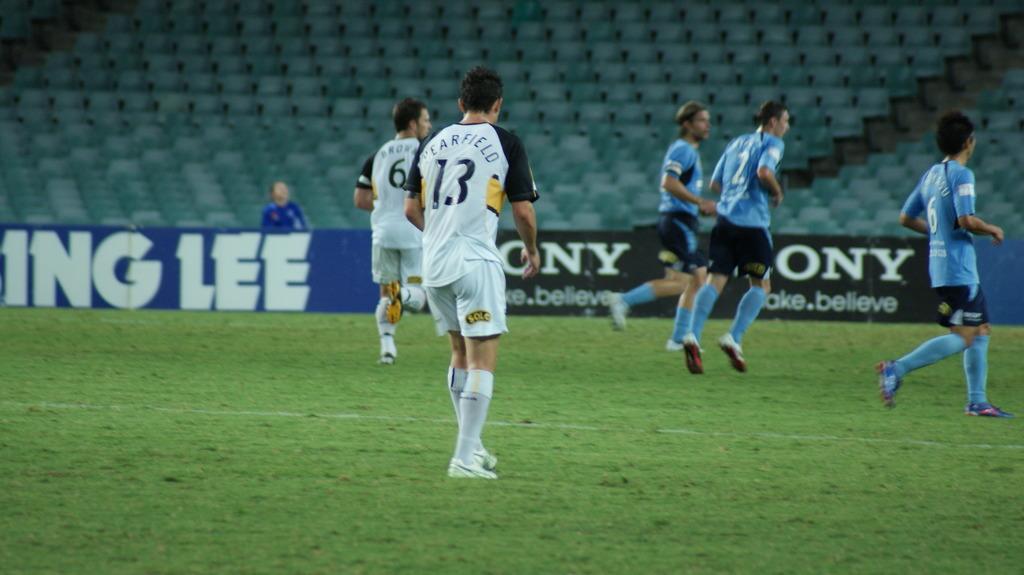Please provide a concise description of this image. In this image we can see persons standing on the ground and an advertisement. 